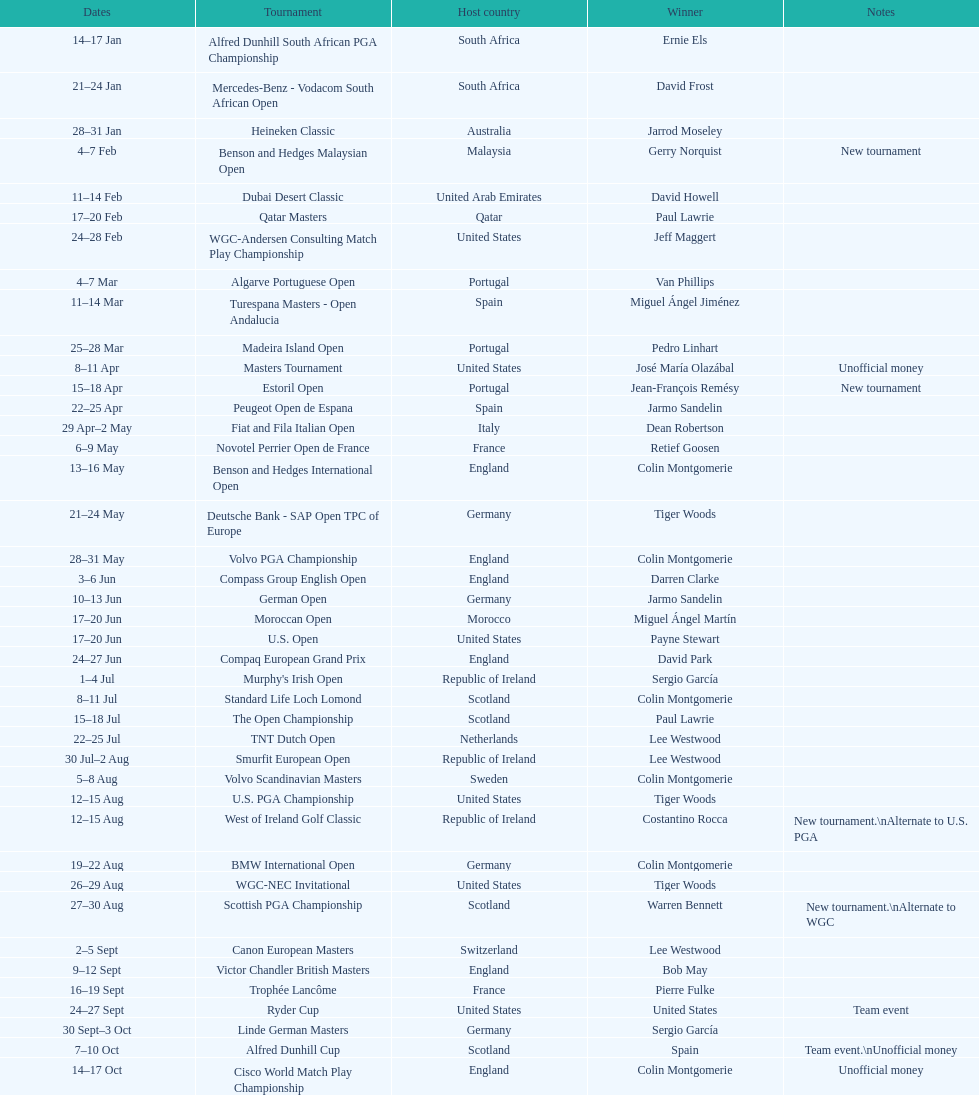Other than qatar masters, name a tournament that was in february. Dubai Desert Classic. 